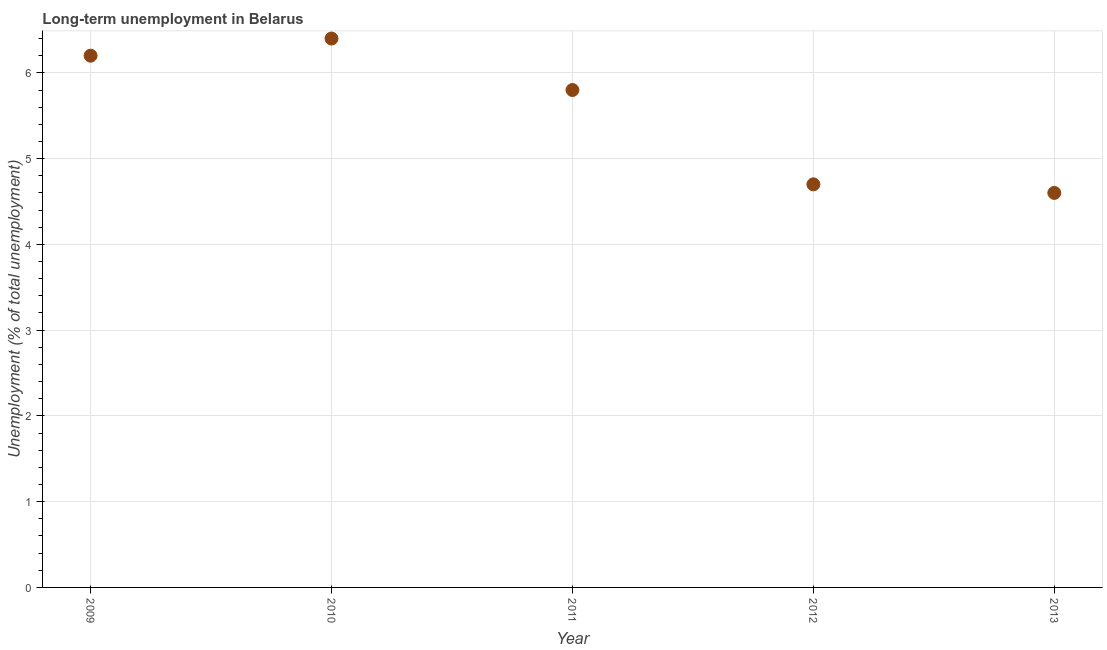What is the long-term unemployment in 2013?
Keep it short and to the point. 4.6. Across all years, what is the maximum long-term unemployment?
Keep it short and to the point. 6.4. Across all years, what is the minimum long-term unemployment?
Offer a terse response. 4.6. In which year was the long-term unemployment minimum?
Give a very brief answer. 2013. What is the sum of the long-term unemployment?
Give a very brief answer. 27.7. What is the difference between the long-term unemployment in 2011 and 2012?
Your answer should be very brief. 1.1. What is the average long-term unemployment per year?
Make the answer very short. 5.54. What is the median long-term unemployment?
Make the answer very short. 5.8. Do a majority of the years between 2010 and 2012 (inclusive) have long-term unemployment greater than 5.6 %?
Offer a very short reply. Yes. What is the ratio of the long-term unemployment in 2010 to that in 2011?
Provide a succinct answer. 1.1. Is the long-term unemployment in 2010 less than that in 2012?
Keep it short and to the point. No. What is the difference between the highest and the second highest long-term unemployment?
Give a very brief answer. 0.2. What is the difference between the highest and the lowest long-term unemployment?
Your answer should be compact. 1.8. Does the long-term unemployment monotonically increase over the years?
Provide a succinct answer. No. Are the values on the major ticks of Y-axis written in scientific E-notation?
Offer a terse response. No. Does the graph contain grids?
Make the answer very short. Yes. What is the title of the graph?
Provide a short and direct response. Long-term unemployment in Belarus. What is the label or title of the Y-axis?
Offer a terse response. Unemployment (% of total unemployment). What is the Unemployment (% of total unemployment) in 2009?
Provide a succinct answer. 6.2. What is the Unemployment (% of total unemployment) in 2010?
Your response must be concise. 6.4. What is the Unemployment (% of total unemployment) in 2011?
Provide a succinct answer. 5.8. What is the Unemployment (% of total unemployment) in 2012?
Make the answer very short. 4.7. What is the Unemployment (% of total unemployment) in 2013?
Offer a very short reply. 4.6. What is the difference between the Unemployment (% of total unemployment) in 2009 and 2012?
Keep it short and to the point. 1.5. What is the difference between the Unemployment (% of total unemployment) in 2010 and 2012?
Ensure brevity in your answer.  1.7. What is the difference between the Unemployment (% of total unemployment) in 2012 and 2013?
Your answer should be very brief. 0.1. What is the ratio of the Unemployment (% of total unemployment) in 2009 to that in 2011?
Offer a very short reply. 1.07. What is the ratio of the Unemployment (% of total unemployment) in 2009 to that in 2012?
Provide a succinct answer. 1.32. What is the ratio of the Unemployment (% of total unemployment) in 2009 to that in 2013?
Offer a terse response. 1.35. What is the ratio of the Unemployment (% of total unemployment) in 2010 to that in 2011?
Ensure brevity in your answer.  1.1. What is the ratio of the Unemployment (% of total unemployment) in 2010 to that in 2012?
Offer a terse response. 1.36. What is the ratio of the Unemployment (% of total unemployment) in 2010 to that in 2013?
Your response must be concise. 1.39. What is the ratio of the Unemployment (% of total unemployment) in 2011 to that in 2012?
Keep it short and to the point. 1.23. What is the ratio of the Unemployment (% of total unemployment) in 2011 to that in 2013?
Ensure brevity in your answer.  1.26. What is the ratio of the Unemployment (% of total unemployment) in 2012 to that in 2013?
Offer a very short reply. 1.02. 